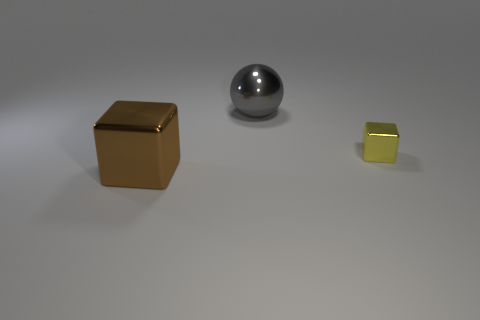Add 3 blue metallic spheres. How many objects exist? 6 Subtract all brown cubes. How many cubes are left? 1 Subtract 0 green cylinders. How many objects are left? 3 Subtract all blocks. How many objects are left? 1 Subtract 2 cubes. How many cubes are left? 0 Subtract all cyan balls. Subtract all gray blocks. How many balls are left? 1 Subtract all yellow spheres. How many brown cubes are left? 1 Subtract all gray shiny things. Subtract all big gray metal balls. How many objects are left? 1 Add 3 tiny cubes. How many tiny cubes are left? 4 Add 1 red metal cylinders. How many red metal cylinders exist? 1 